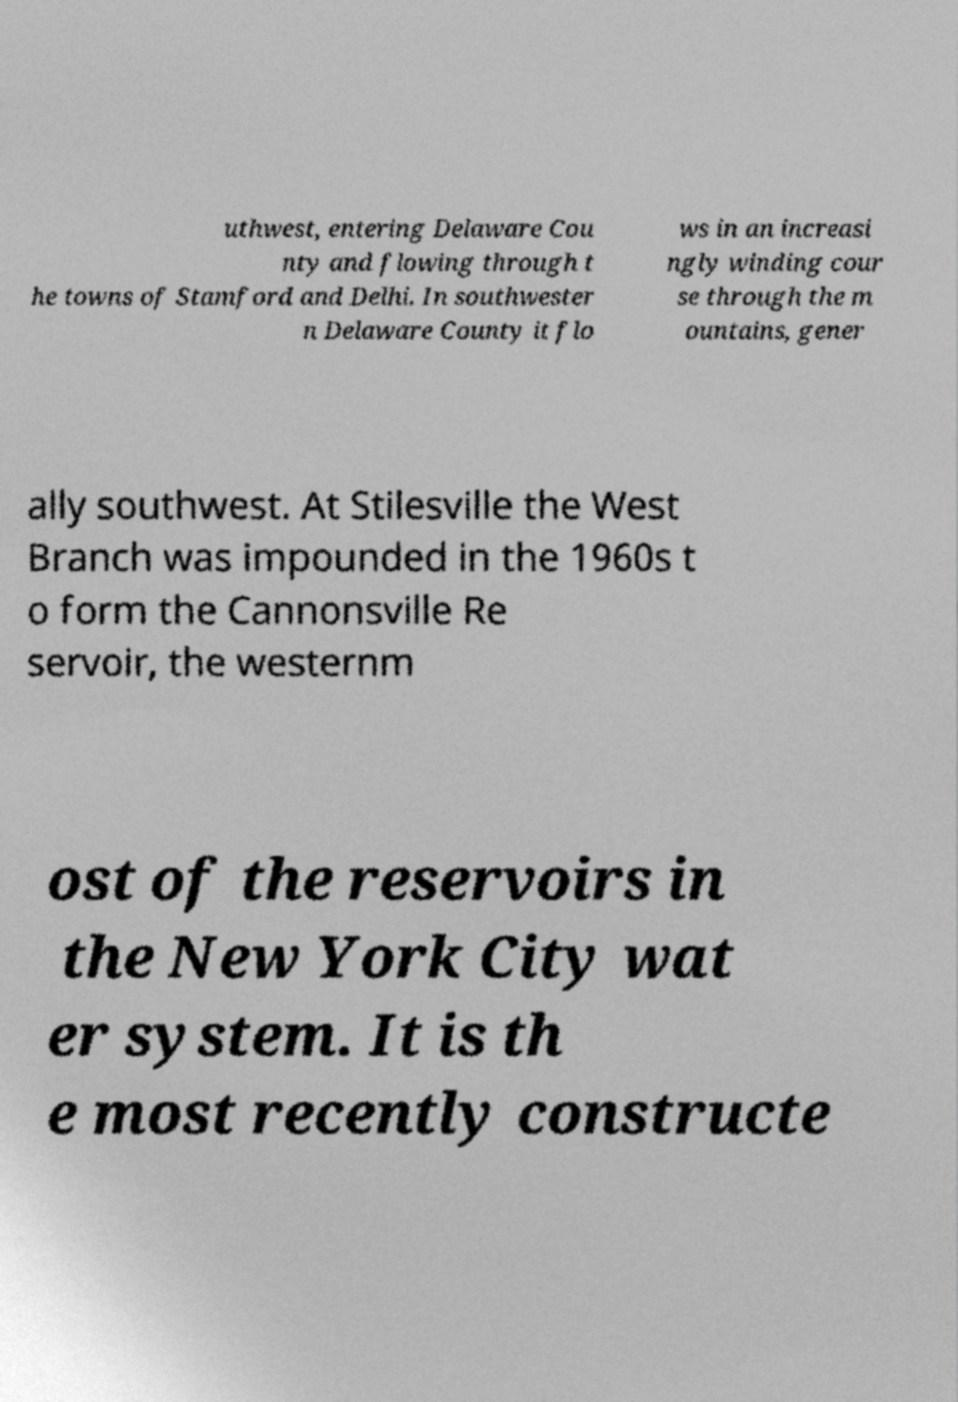What messages or text are displayed in this image? I need them in a readable, typed format. uthwest, entering Delaware Cou nty and flowing through t he towns of Stamford and Delhi. In southwester n Delaware County it flo ws in an increasi ngly winding cour se through the m ountains, gener ally southwest. At Stilesville the West Branch was impounded in the 1960s t o form the Cannonsville Re servoir, the westernm ost of the reservoirs in the New York City wat er system. It is th e most recently constructe 